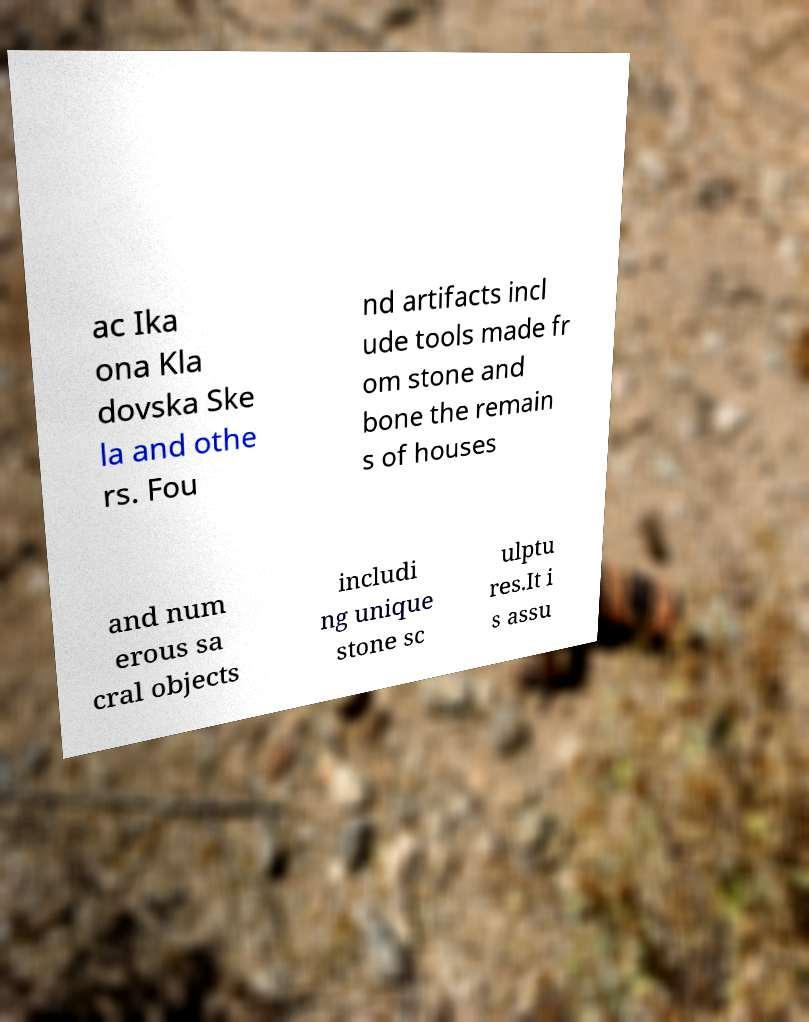Can you accurately transcribe the text from the provided image for me? ac Ika ona Kla dovska Ske la and othe rs. Fou nd artifacts incl ude tools made fr om stone and bone the remain s of houses and num erous sa cral objects includi ng unique stone sc ulptu res.It i s assu 